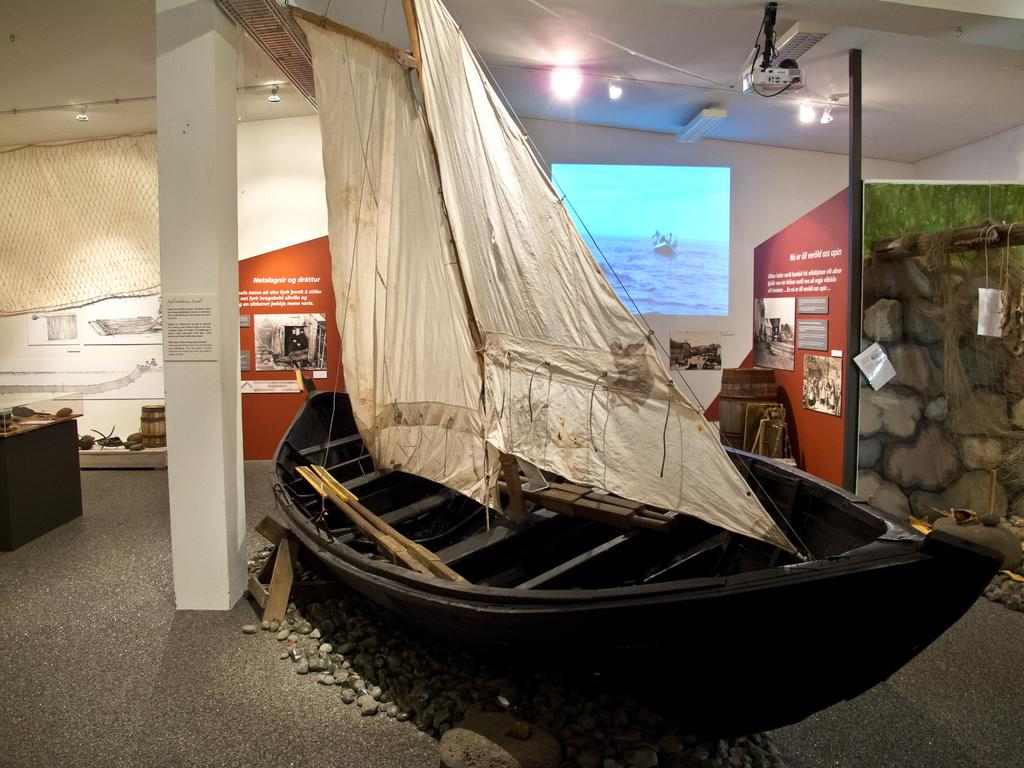What is the main subject of the image? The main subject of the image is a boat. What can be seen in the image besides the boat? There are two white clothes, boards, a screen, and lights visible in the image. Can you describe the background of the image? The background of the image includes boards and a screen. What type of lighting is present in the image? There are lights visible in the image. How many apples are hanging from the boat in the image? There are no apples present in the image. Can you describe the heat emitted by the lights in the image? The image does not provide information about the heat emitted by the lights; it only shows their presence. 